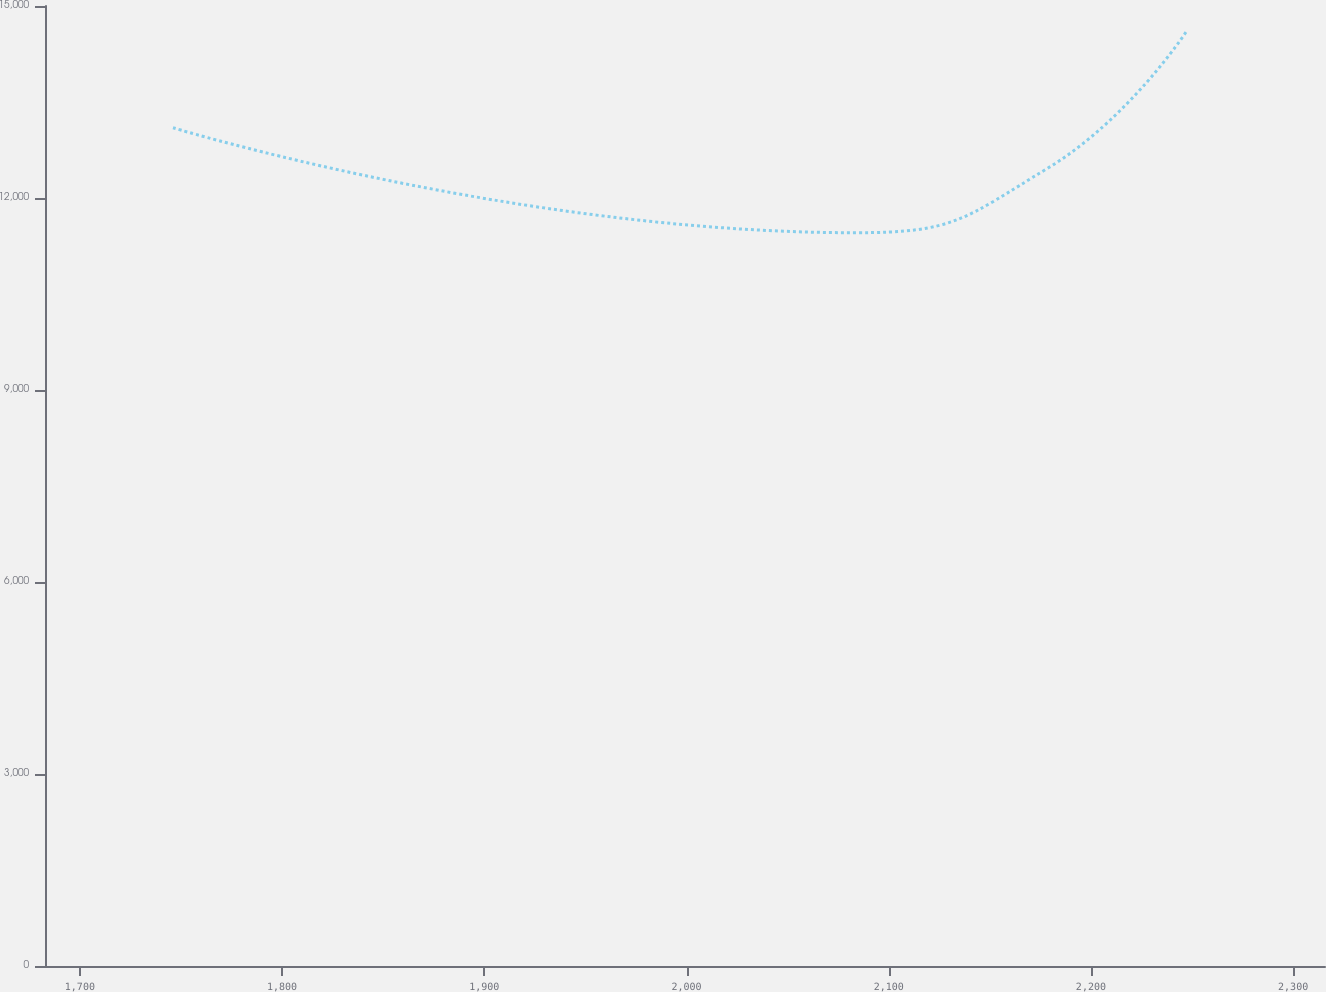Convert chart to OTSL. <chart><loc_0><loc_0><loc_500><loc_500><line_chart><ecel><fcel>Unnamed: 1<nl><fcel>1746.05<fcel>13097.5<nl><fcel>2083.53<fcel>11457.3<nl><fcel>2178.74<fcel>12467.6<nl><fcel>2247.01<fcel>14591.4<nl><fcel>2379.06<fcel>15304<nl></chart> 